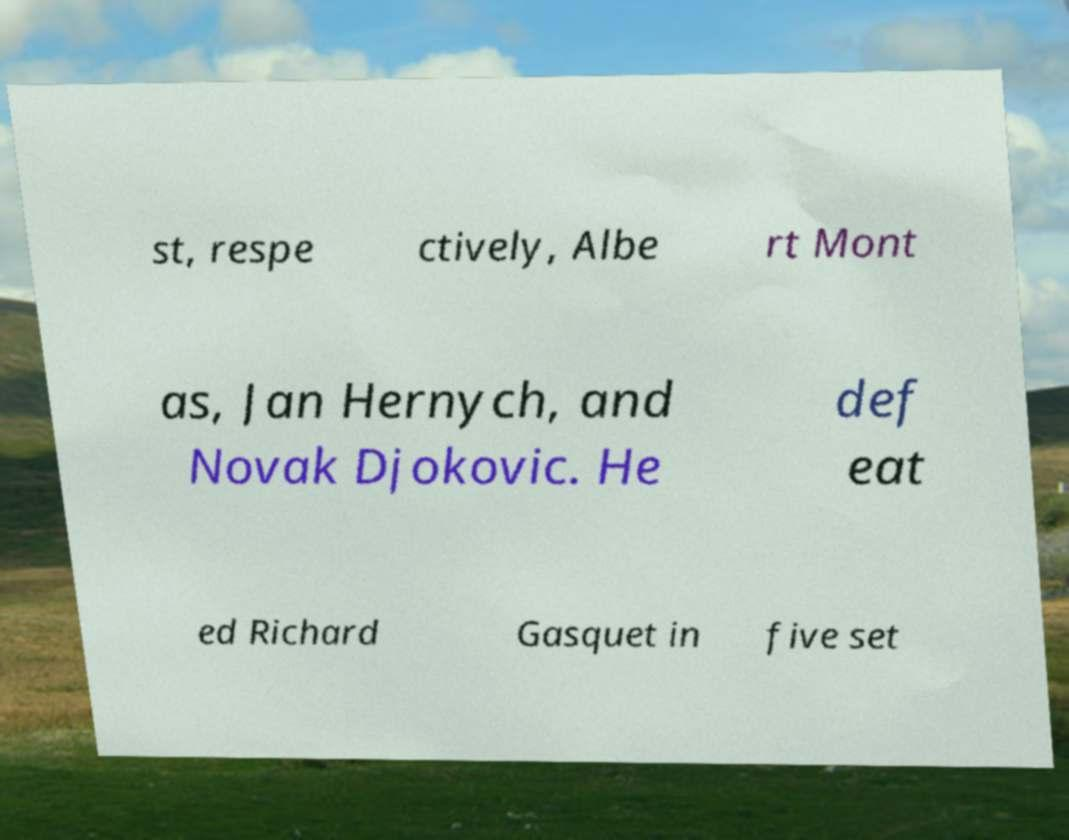Please identify and transcribe the text found in this image. st, respe ctively, Albe rt Mont as, Jan Hernych, and Novak Djokovic. He def eat ed Richard Gasquet in five set 